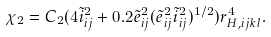Convert formula to latex. <formula><loc_0><loc_0><loc_500><loc_500>\chi _ { 2 } = C _ { 2 } ( 4 \tilde { i } _ { i j } ^ { 2 } + 0 . 2 \tilde { e } _ { i j } ^ { 2 } ( \tilde { e } _ { i j } ^ { 2 } \tilde { i } _ { i j } ^ { 2 } ) ^ { 1 / 2 } ) r _ { H , i j k l } ^ { 4 } .</formula> 